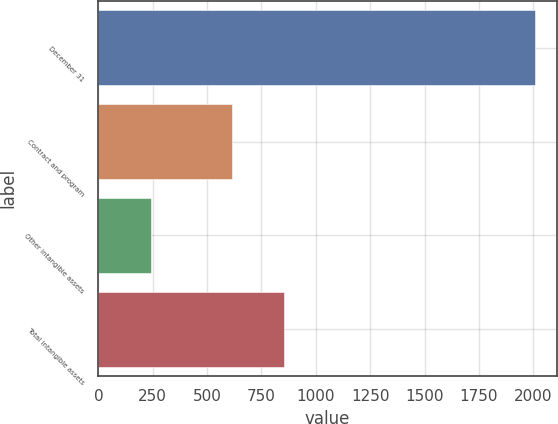Convert chart. <chart><loc_0><loc_0><loc_500><loc_500><bar_chart><fcel>December 31<fcel>Contract and program<fcel>Other intangible assets<fcel>Total intangible assets<nl><fcel>2008<fcel>613<fcel>242<fcel>855<nl></chart> 